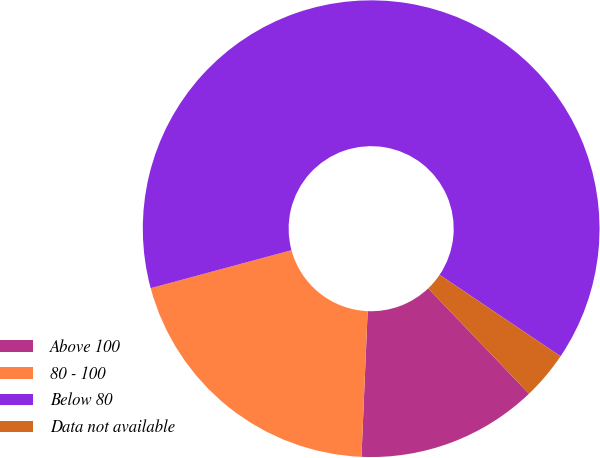Convert chart to OTSL. <chart><loc_0><loc_0><loc_500><loc_500><pie_chart><fcel>Above 100<fcel>80 - 100<fcel>Below 80<fcel>Data not available<nl><fcel>12.82%<fcel>20.13%<fcel>63.63%<fcel>3.42%<nl></chart> 